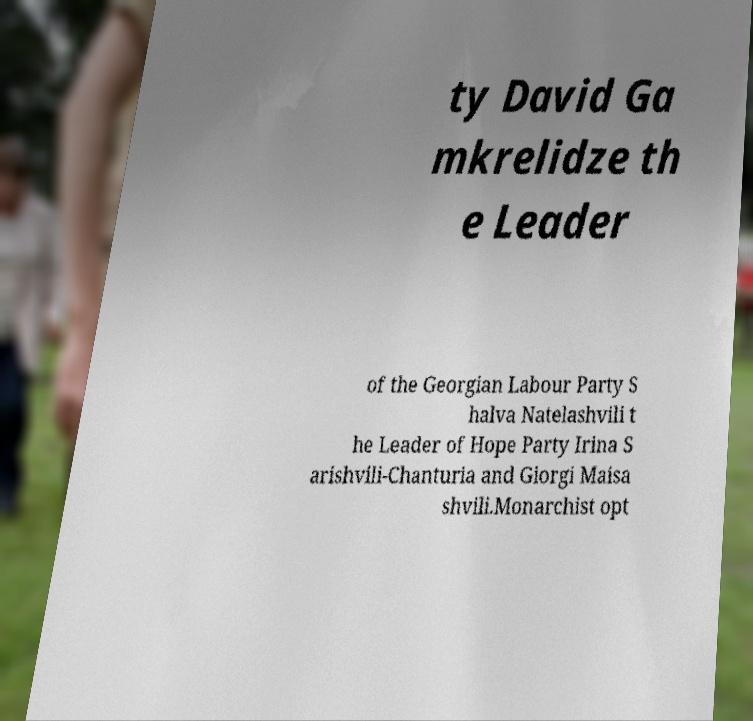There's text embedded in this image that I need extracted. Can you transcribe it verbatim? ty David Ga mkrelidze th e Leader of the Georgian Labour Party S halva Natelashvili t he Leader of Hope Party Irina S arishvili-Chanturia and Giorgi Maisa shvili.Monarchist opt 